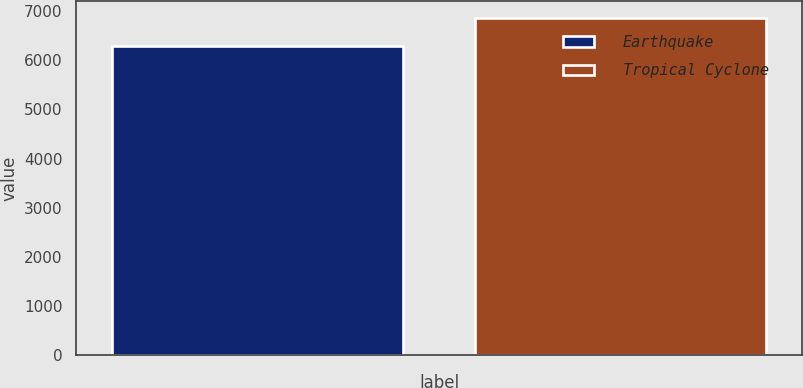Convert chart to OTSL. <chart><loc_0><loc_0><loc_500><loc_500><bar_chart><fcel>Earthquake<fcel>Tropical Cyclone<nl><fcel>6299<fcel>6863<nl></chart> 